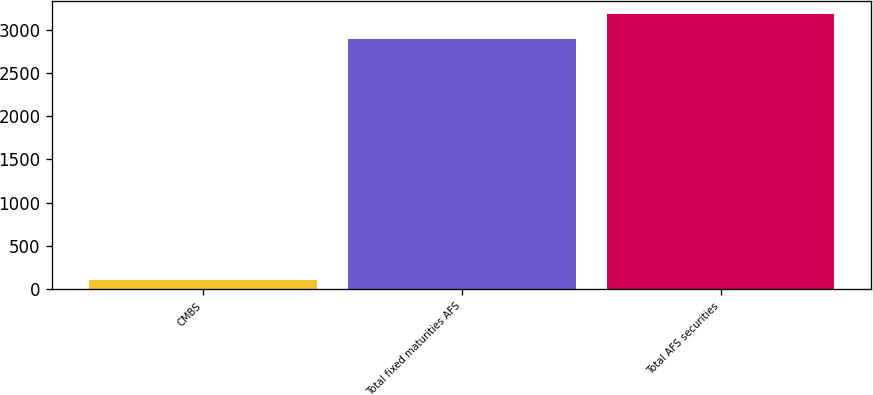<chart> <loc_0><loc_0><loc_500><loc_500><bar_chart><fcel>CMBS<fcel>Total fixed maturities AFS<fcel>Total AFS securities<nl><fcel>105<fcel>2892<fcel>3174.5<nl></chart> 